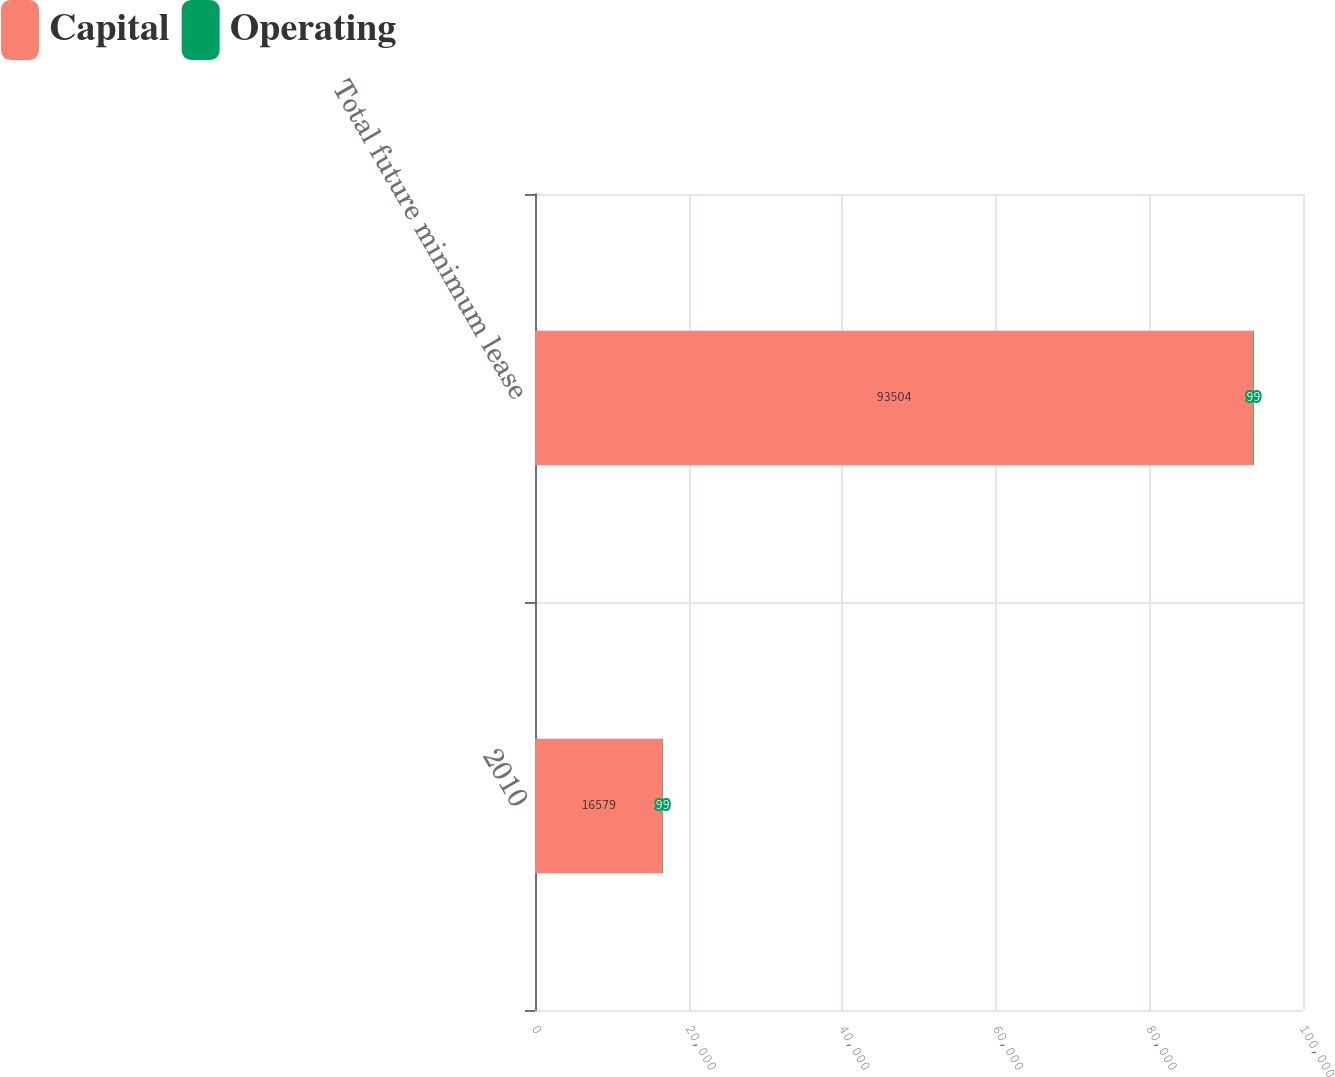<chart> <loc_0><loc_0><loc_500><loc_500><stacked_bar_chart><ecel><fcel>2010<fcel>Total future minimum lease<nl><fcel>Capital<fcel>16579<fcel>93504<nl><fcel>Operating<fcel>99<fcel>99<nl></chart> 